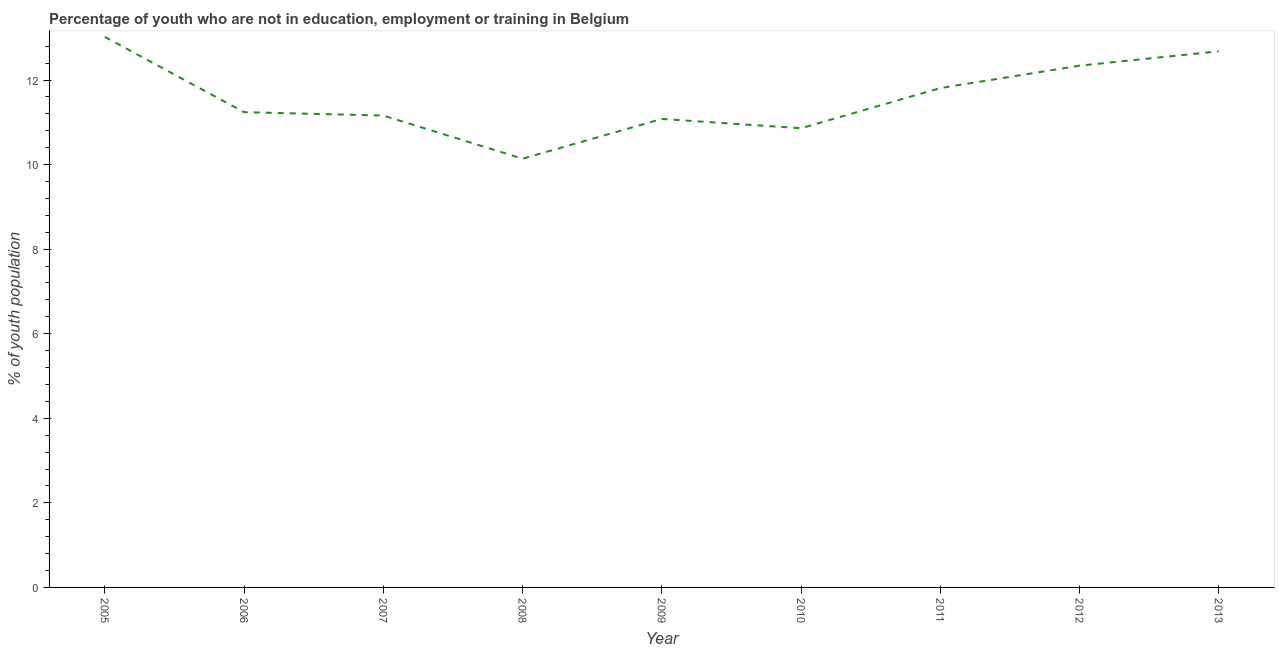What is the unemployed youth population in 2009?
Your answer should be very brief. 11.08. Across all years, what is the maximum unemployed youth population?
Provide a succinct answer. 13.02. Across all years, what is the minimum unemployed youth population?
Offer a terse response. 10.14. In which year was the unemployed youth population maximum?
Ensure brevity in your answer.  2005. What is the sum of the unemployed youth population?
Keep it short and to the point. 104.33. What is the difference between the unemployed youth population in 2006 and 2013?
Ensure brevity in your answer.  -1.44. What is the average unemployed youth population per year?
Your answer should be very brief. 11.59. What is the median unemployed youth population?
Offer a terse response. 11.24. In how many years, is the unemployed youth population greater than 10.8 %?
Ensure brevity in your answer.  8. Do a majority of the years between 2010 and 2006 (inclusive) have unemployed youth population greater than 0.4 %?
Provide a succinct answer. Yes. What is the ratio of the unemployed youth population in 2009 to that in 2012?
Keep it short and to the point. 0.9. What is the difference between the highest and the second highest unemployed youth population?
Ensure brevity in your answer.  0.34. Is the sum of the unemployed youth population in 2008 and 2013 greater than the maximum unemployed youth population across all years?
Keep it short and to the point. Yes. What is the difference between the highest and the lowest unemployed youth population?
Ensure brevity in your answer.  2.88. Does the unemployed youth population monotonically increase over the years?
Keep it short and to the point. No. How many lines are there?
Your answer should be compact. 1. How many years are there in the graph?
Give a very brief answer. 9. What is the title of the graph?
Keep it short and to the point. Percentage of youth who are not in education, employment or training in Belgium. What is the label or title of the Y-axis?
Offer a terse response. % of youth population. What is the % of youth population in 2005?
Your answer should be compact. 13.02. What is the % of youth population of 2006?
Offer a very short reply. 11.24. What is the % of youth population in 2007?
Keep it short and to the point. 11.16. What is the % of youth population in 2008?
Ensure brevity in your answer.  10.14. What is the % of youth population in 2009?
Keep it short and to the point. 11.08. What is the % of youth population in 2010?
Ensure brevity in your answer.  10.86. What is the % of youth population in 2011?
Your answer should be compact. 11.81. What is the % of youth population in 2012?
Offer a very short reply. 12.34. What is the % of youth population of 2013?
Keep it short and to the point. 12.68. What is the difference between the % of youth population in 2005 and 2006?
Provide a short and direct response. 1.78. What is the difference between the % of youth population in 2005 and 2007?
Offer a terse response. 1.86. What is the difference between the % of youth population in 2005 and 2008?
Your answer should be very brief. 2.88. What is the difference between the % of youth population in 2005 and 2009?
Offer a terse response. 1.94. What is the difference between the % of youth population in 2005 and 2010?
Offer a very short reply. 2.16. What is the difference between the % of youth population in 2005 and 2011?
Ensure brevity in your answer.  1.21. What is the difference between the % of youth population in 2005 and 2012?
Provide a succinct answer. 0.68. What is the difference between the % of youth population in 2005 and 2013?
Provide a succinct answer. 0.34. What is the difference between the % of youth population in 2006 and 2008?
Give a very brief answer. 1.1. What is the difference between the % of youth population in 2006 and 2009?
Your answer should be compact. 0.16. What is the difference between the % of youth population in 2006 and 2010?
Offer a terse response. 0.38. What is the difference between the % of youth population in 2006 and 2011?
Provide a short and direct response. -0.57. What is the difference between the % of youth population in 2006 and 2013?
Provide a short and direct response. -1.44. What is the difference between the % of youth population in 2007 and 2008?
Offer a terse response. 1.02. What is the difference between the % of youth population in 2007 and 2011?
Your response must be concise. -0.65. What is the difference between the % of youth population in 2007 and 2012?
Offer a terse response. -1.18. What is the difference between the % of youth population in 2007 and 2013?
Offer a very short reply. -1.52. What is the difference between the % of youth population in 2008 and 2009?
Provide a short and direct response. -0.94. What is the difference between the % of youth population in 2008 and 2010?
Make the answer very short. -0.72. What is the difference between the % of youth population in 2008 and 2011?
Your answer should be compact. -1.67. What is the difference between the % of youth population in 2008 and 2013?
Give a very brief answer. -2.54. What is the difference between the % of youth population in 2009 and 2010?
Your answer should be compact. 0.22. What is the difference between the % of youth population in 2009 and 2011?
Your response must be concise. -0.73. What is the difference between the % of youth population in 2009 and 2012?
Provide a short and direct response. -1.26. What is the difference between the % of youth population in 2010 and 2011?
Provide a short and direct response. -0.95. What is the difference between the % of youth population in 2010 and 2012?
Keep it short and to the point. -1.48. What is the difference between the % of youth population in 2010 and 2013?
Provide a short and direct response. -1.82. What is the difference between the % of youth population in 2011 and 2012?
Make the answer very short. -0.53. What is the difference between the % of youth population in 2011 and 2013?
Provide a short and direct response. -0.87. What is the difference between the % of youth population in 2012 and 2013?
Keep it short and to the point. -0.34. What is the ratio of the % of youth population in 2005 to that in 2006?
Provide a succinct answer. 1.16. What is the ratio of the % of youth population in 2005 to that in 2007?
Your response must be concise. 1.17. What is the ratio of the % of youth population in 2005 to that in 2008?
Make the answer very short. 1.28. What is the ratio of the % of youth population in 2005 to that in 2009?
Your response must be concise. 1.18. What is the ratio of the % of youth population in 2005 to that in 2010?
Provide a short and direct response. 1.2. What is the ratio of the % of youth population in 2005 to that in 2011?
Offer a very short reply. 1.1. What is the ratio of the % of youth population in 2005 to that in 2012?
Keep it short and to the point. 1.05. What is the ratio of the % of youth population in 2006 to that in 2008?
Give a very brief answer. 1.11. What is the ratio of the % of youth population in 2006 to that in 2010?
Your answer should be very brief. 1.03. What is the ratio of the % of youth population in 2006 to that in 2012?
Ensure brevity in your answer.  0.91. What is the ratio of the % of youth population in 2006 to that in 2013?
Ensure brevity in your answer.  0.89. What is the ratio of the % of youth population in 2007 to that in 2008?
Provide a succinct answer. 1.1. What is the ratio of the % of youth population in 2007 to that in 2010?
Give a very brief answer. 1.03. What is the ratio of the % of youth population in 2007 to that in 2011?
Offer a very short reply. 0.94. What is the ratio of the % of youth population in 2007 to that in 2012?
Give a very brief answer. 0.9. What is the ratio of the % of youth population in 2008 to that in 2009?
Provide a succinct answer. 0.92. What is the ratio of the % of youth population in 2008 to that in 2010?
Ensure brevity in your answer.  0.93. What is the ratio of the % of youth population in 2008 to that in 2011?
Keep it short and to the point. 0.86. What is the ratio of the % of youth population in 2008 to that in 2012?
Your response must be concise. 0.82. What is the ratio of the % of youth population in 2009 to that in 2011?
Make the answer very short. 0.94. What is the ratio of the % of youth population in 2009 to that in 2012?
Offer a terse response. 0.9. What is the ratio of the % of youth population in 2009 to that in 2013?
Offer a very short reply. 0.87. What is the ratio of the % of youth population in 2010 to that in 2013?
Give a very brief answer. 0.86. What is the ratio of the % of youth population in 2012 to that in 2013?
Provide a short and direct response. 0.97. 